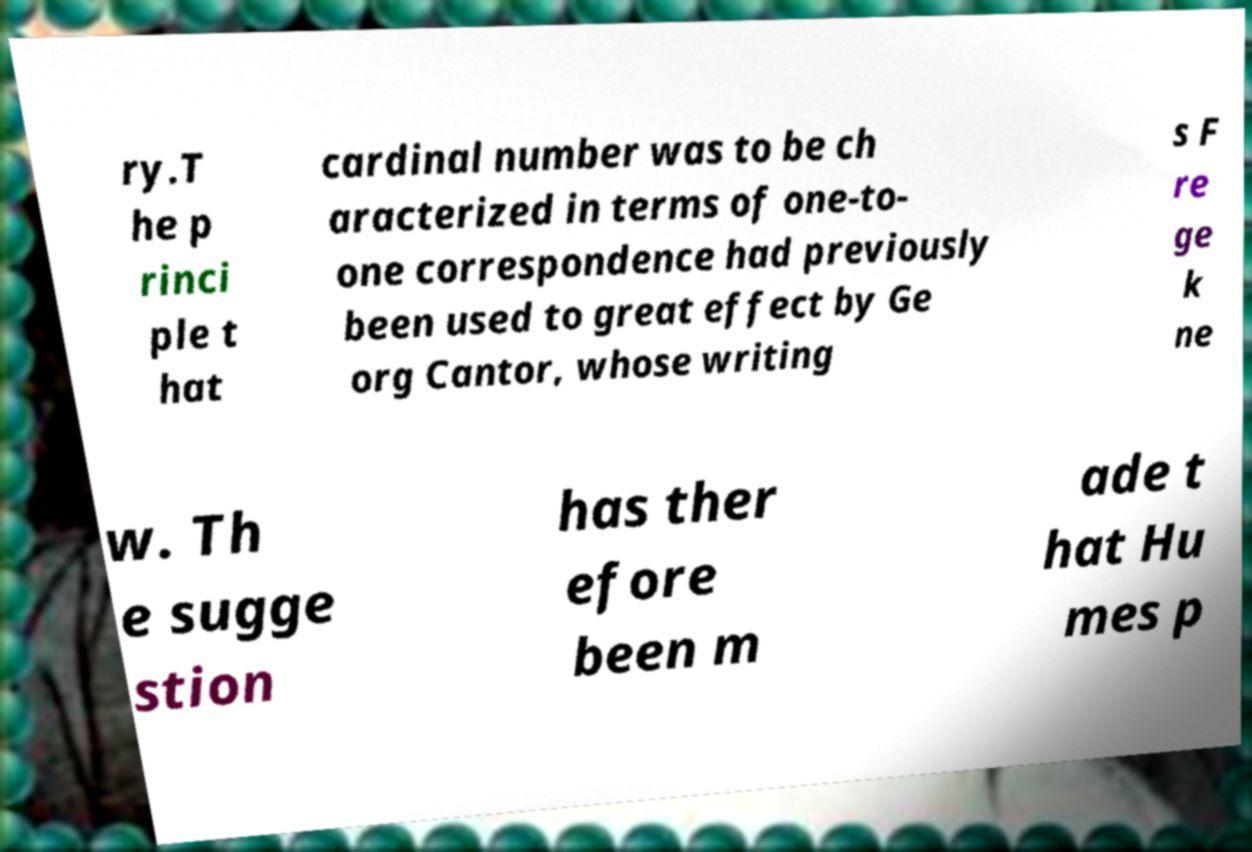Can you read and provide the text displayed in the image?This photo seems to have some interesting text. Can you extract and type it out for me? ry.T he p rinci ple t hat cardinal number was to be ch aracterized in terms of one-to- one correspondence had previously been used to great effect by Ge org Cantor, whose writing s F re ge k ne w. Th e sugge stion has ther efore been m ade t hat Hu mes p 